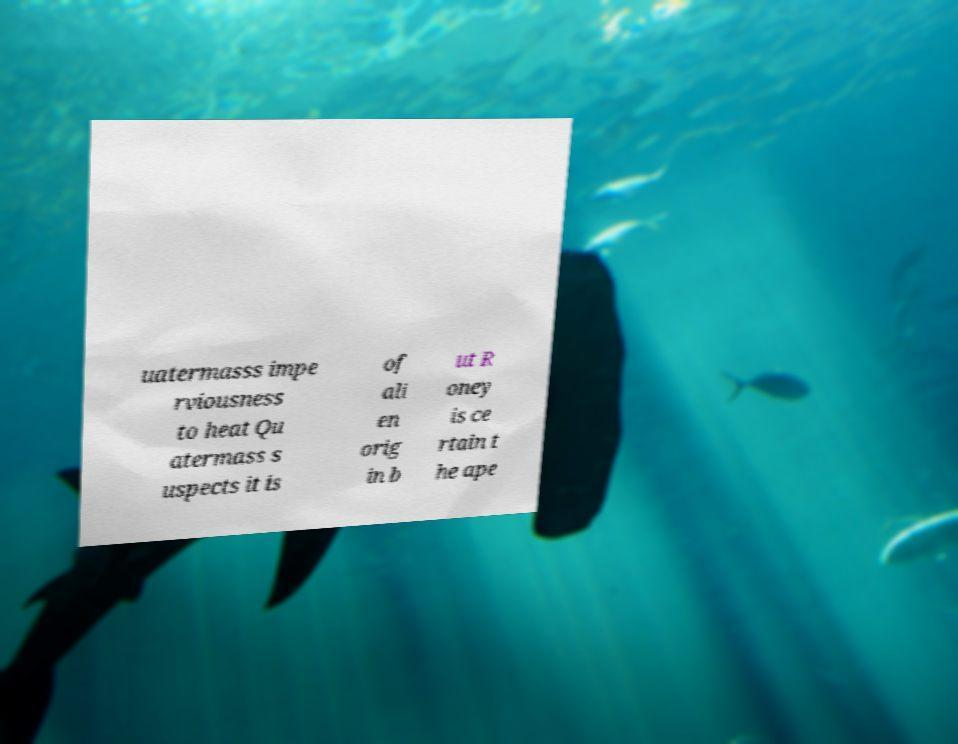Can you accurately transcribe the text from the provided image for me? uatermasss impe rviousness to heat Qu atermass s uspects it is of ali en orig in b ut R oney is ce rtain t he ape 